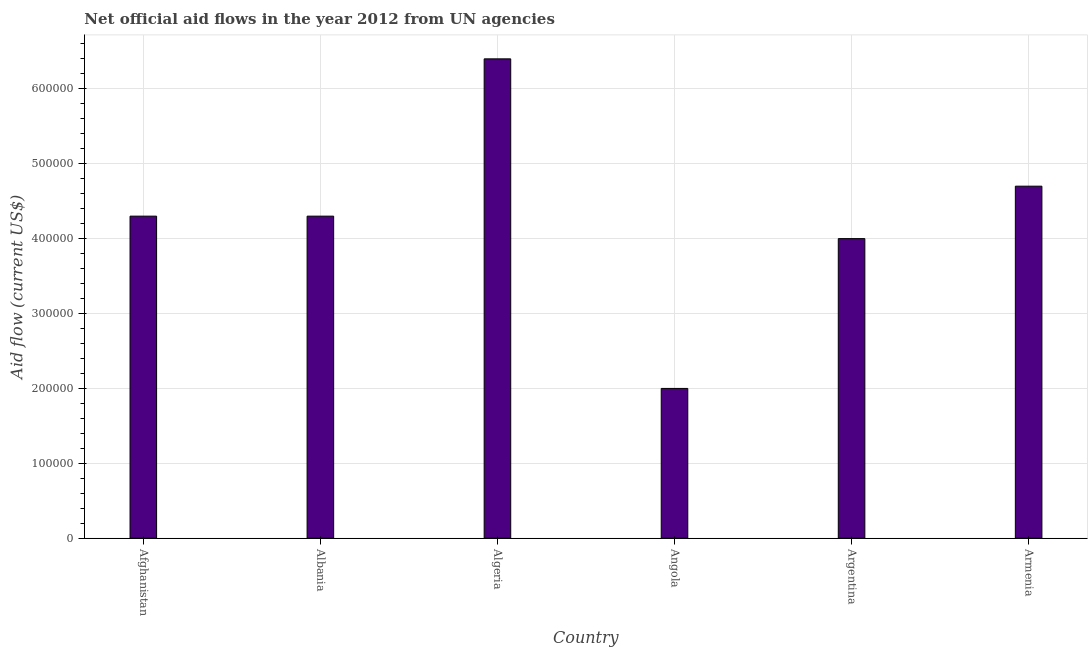What is the title of the graph?
Your response must be concise. Net official aid flows in the year 2012 from UN agencies. What is the label or title of the X-axis?
Provide a short and direct response. Country. What is the label or title of the Y-axis?
Your response must be concise. Aid flow (current US$). Across all countries, what is the maximum net official flows from un agencies?
Your answer should be very brief. 6.40e+05. Across all countries, what is the minimum net official flows from un agencies?
Your response must be concise. 2.00e+05. In which country was the net official flows from un agencies maximum?
Offer a very short reply. Algeria. In which country was the net official flows from un agencies minimum?
Ensure brevity in your answer.  Angola. What is the sum of the net official flows from un agencies?
Provide a short and direct response. 2.57e+06. What is the difference between the net official flows from un agencies in Argentina and Armenia?
Give a very brief answer. -7.00e+04. What is the average net official flows from un agencies per country?
Provide a succinct answer. 4.28e+05. What is the median net official flows from un agencies?
Your answer should be compact. 4.30e+05. What is the ratio of the net official flows from un agencies in Algeria to that in Armenia?
Offer a very short reply. 1.36. What is the difference between the highest and the second highest net official flows from un agencies?
Your response must be concise. 1.70e+05. What is the difference between the highest and the lowest net official flows from un agencies?
Offer a terse response. 4.40e+05. In how many countries, is the net official flows from un agencies greater than the average net official flows from un agencies taken over all countries?
Make the answer very short. 4. How many countries are there in the graph?
Offer a terse response. 6. What is the Aid flow (current US$) in Algeria?
Offer a very short reply. 6.40e+05. What is the Aid flow (current US$) in Angola?
Your response must be concise. 2.00e+05. What is the Aid flow (current US$) of Argentina?
Your response must be concise. 4.00e+05. What is the difference between the Aid flow (current US$) in Afghanistan and Albania?
Ensure brevity in your answer.  0. What is the difference between the Aid flow (current US$) in Afghanistan and Algeria?
Offer a terse response. -2.10e+05. What is the difference between the Aid flow (current US$) in Albania and Algeria?
Ensure brevity in your answer.  -2.10e+05. What is the difference between the Aid flow (current US$) in Albania and Angola?
Give a very brief answer. 2.30e+05. What is the difference between the Aid flow (current US$) in Algeria and Angola?
Provide a short and direct response. 4.40e+05. What is the difference between the Aid flow (current US$) in Angola and Armenia?
Your answer should be very brief. -2.70e+05. What is the difference between the Aid flow (current US$) in Argentina and Armenia?
Provide a succinct answer. -7.00e+04. What is the ratio of the Aid flow (current US$) in Afghanistan to that in Albania?
Provide a succinct answer. 1. What is the ratio of the Aid flow (current US$) in Afghanistan to that in Algeria?
Ensure brevity in your answer.  0.67. What is the ratio of the Aid flow (current US$) in Afghanistan to that in Angola?
Your answer should be compact. 2.15. What is the ratio of the Aid flow (current US$) in Afghanistan to that in Argentina?
Offer a terse response. 1.07. What is the ratio of the Aid flow (current US$) in Afghanistan to that in Armenia?
Offer a terse response. 0.92. What is the ratio of the Aid flow (current US$) in Albania to that in Algeria?
Ensure brevity in your answer.  0.67. What is the ratio of the Aid flow (current US$) in Albania to that in Angola?
Ensure brevity in your answer.  2.15. What is the ratio of the Aid flow (current US$) in Albania to that in Argentina?
Your answer should be compact. 1.07. What is the ratio of the Aid flow (current US$) in Albania to that in Armenia?
Give a very brief answer. 0.92. What is the ratio of the Aid flow (current US$) in Algeria to that in Angola?
Ensure brevity in your answer.  3.2. What is the ratio of the Aid flow (current US$) in Algeria to that in Armenia?
Ensure brevity in your answer.  1.36. What is the ratio of the Aid flow (current US$) in Angola to that in Armenia?
Provide a short and direct response. 0.43. What is the ratio of the Aid flow (current US$) in Argentina to that in Armenia?
Make the answer very short. 0.85. 